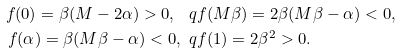Convert formula to latex. <formula><loc_0><loc_0><loc_500><loc_500>f ( 0 ) = \beta ( M - 2 \alpha ) > 0 , \ q & f ( M \beta ) = 2 \beta ( M \beta - \alpha ) < 0 , \\ f ( \alpha ) = \beta ( M \beta - \alpha ) < 0 , \ q & f ( 1 ) = 2 \beta ^ { 2 } > 0 .</formula> 